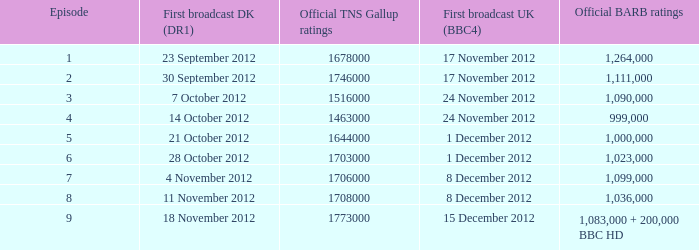What is the BARB ratings of episode 6? 1023000.0. 